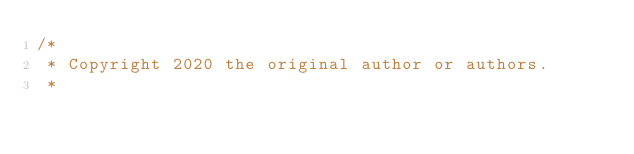Convert code to text. <code><loc_0><loc_0><loc_500><loc_500><_Java_>/*
 * Copyright 2020 the original author or authors.
 *</code> 